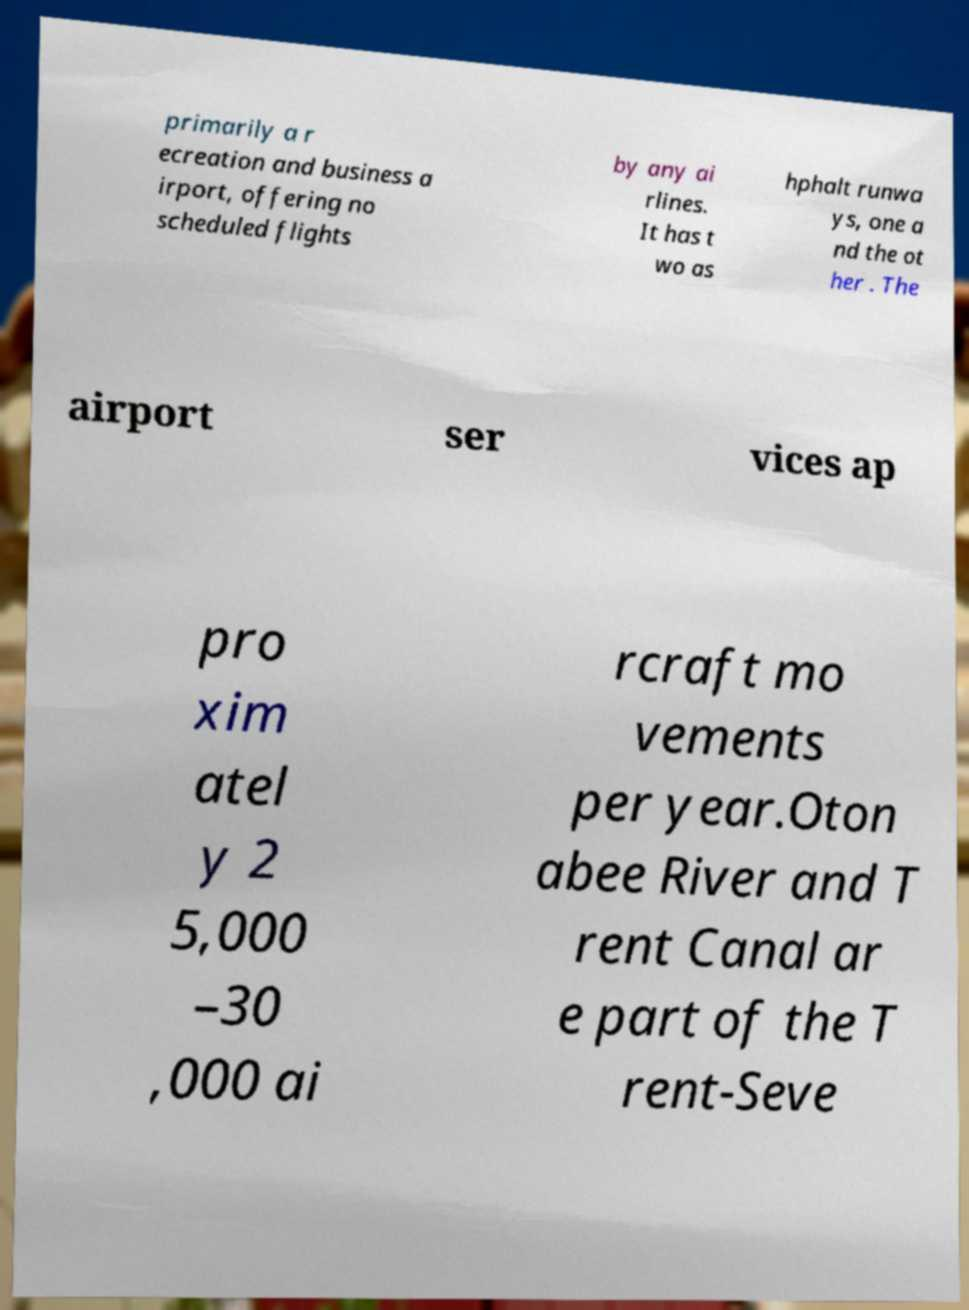Could you assist in decoding the text presented in this image and type it out clearly? primarily a r ecreation and business a irport, offering no scheduled flights by any ai rlines. It has t wo as hphalt runwa ys, one a nd the ot her . The airport ser vices ap pro xim atel y 2 5,000 –30 ,000 ai rcraft mo vements per year.Oton abee River and T rent Canal ar e part of the T rent-Seve 